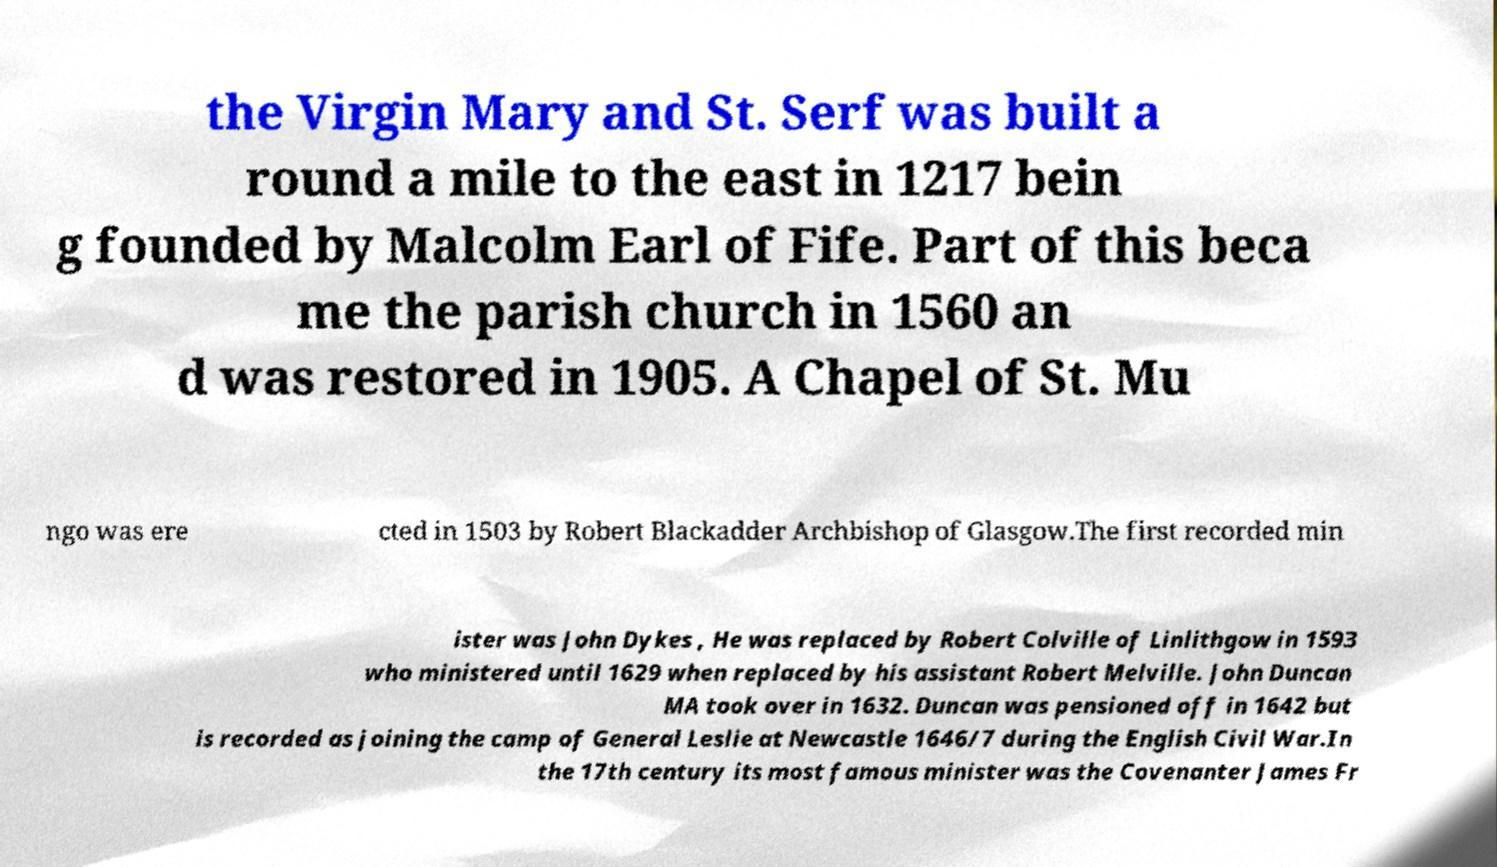For documentation purposes, I need the text within this image transcribed. Could you provide that? the Virgin Mary and St. Serf was built a round a mile to the east in 1217 bein g founded by Malcolm Earl of Fife. Part of this beca me the parish church in 1560 an d was restored in 1905. A Chapel of St. Mu ngo was ere cted in 1503 by Robert Blackadder Archbishop of Glasgow.The first recorded min ister was John Dykes , He was replaced by Robert Colville of Linlithgow in 1593 who ministered until 1629 when replaced by his assistant Robert Melville. John Duncan MA took over in 1632. Duncan was pensioned off in 1642 but is recorded as joining the camp of General Leslie at Newcastle 1646/7 during the English Civil War.In the 17th century its most famous minister was the Covenanter James Fr 